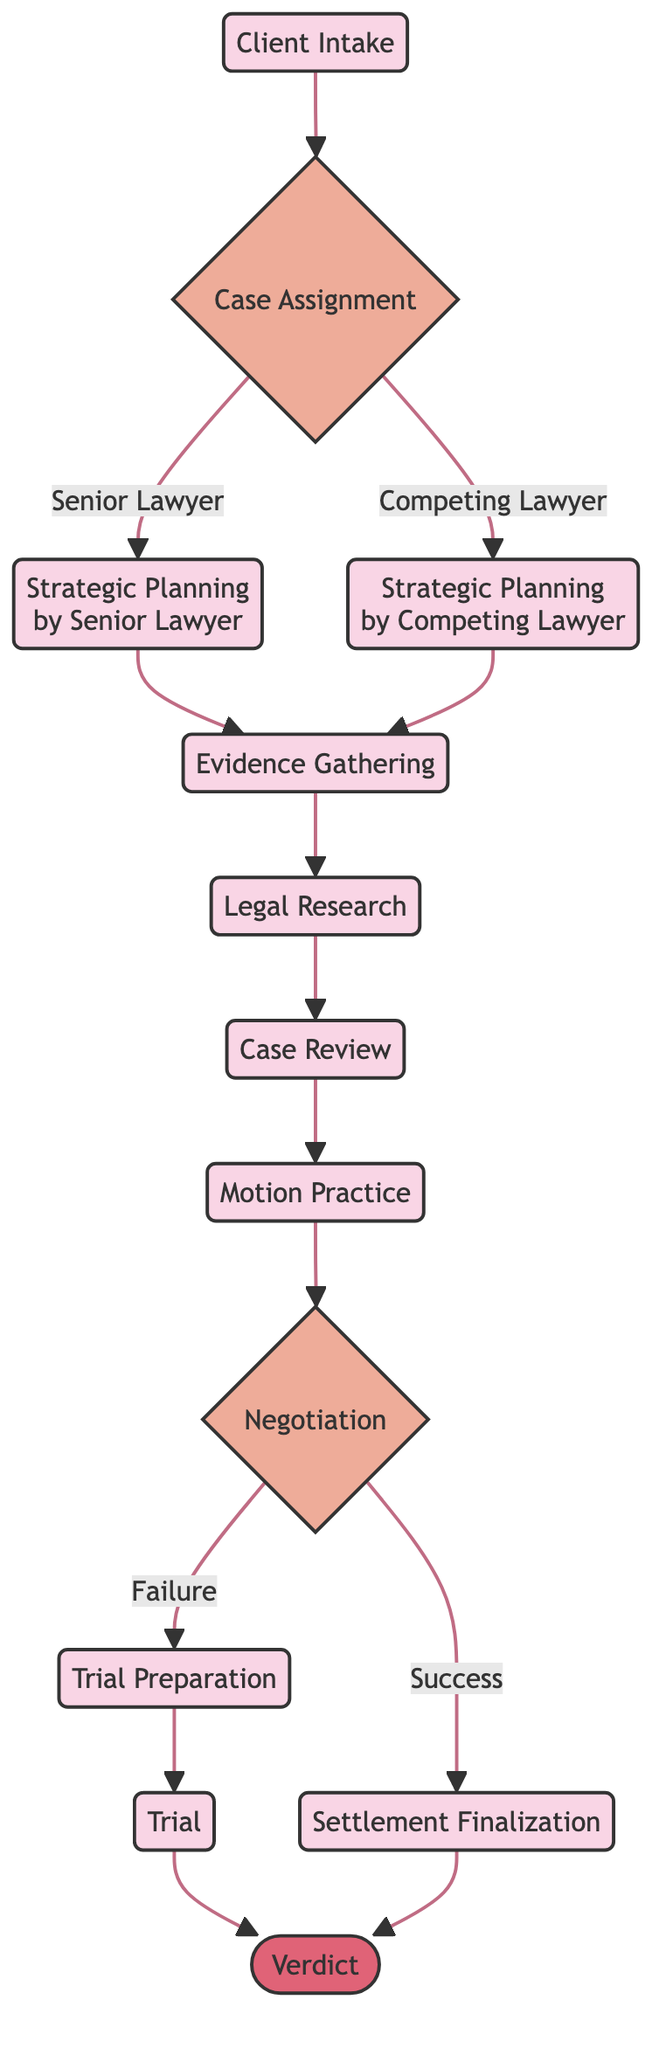What is the first step in the workflow? The diagram starts with the node labeled "Client Intake", which indicates the initial consultation and case acceptance as the first step in the workflow.
Answer: Client Intake How many decision nodes are present in the diagram? There are two decision nodes: "Case Assignment" and "Negotiation". Therefore, the total number of decision nodes is two.
Answer: 2 What happens after the "Evidence Gathering" step? After the "Evidence Gathering" step, the process flows to "Legal Research" as indicated by the directed edge connecting these two nodes.
Answer: Legal Research What are the two possible outcomes of the "Negotiation" decision? The decision node "Negotiation" leads to two possible outcomes: "Success" and "Failure". These outcomes determine the next steps in the process.
Answer: Success, Failure Which process step follows the "Settlement Finalization"? Following the "Settlement Finalization" step, the next step is the "Verdict", which represents receiving the court's decision after completing the settlement process.
Answer: Verdict In what instances does the "Trial Preparation" occur? "Trial Preparation" occurs when the outcome of the "Negotiation" decision is "Failure", indicating that the case did not settle and requires trial preparation instead.
Answer: Failure What role does the "Senior Lawyer" have in the case workflow? The "Senior Lawyer" is responsible for the "Strategic Planning" step if the case is assigned to them as indicated in the "Case Assignment" decision node.
Answer: Strategic Planning by Senior Lawyer What is the final outcome of the workflow? The final outcome of the workflow is the "Verdict", which represents the court's decision after various processes are completed.
Answer: Verdict Which process is connected to the "Case Review"? The "Case Review" process follows "Legal Research" in the workflow as indicated by the directed flow from one to the other.
Answer: Motion Practice 